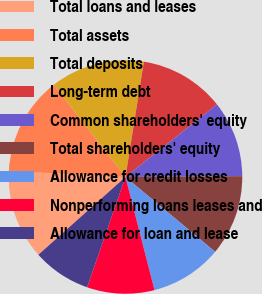Convert chart. <chart><loc_0><loc_0><loc_500><loc_500><pie_chart><fcel>Total loans and leases<fcel>Total assets<fcel>Total deposits<fcel>Long-term debt<fcel>Common shareholders' equity<fcel>Total shareholders' equity<fcel>Allowance for credit losses<fcel>Nonperforming loans leases and<fcel>Allowance for loan and lease<nl><fcel>12.42%<fcel>13.66%<fcel>13.04%<fcel>11.8%<fcel>10.56%<fcel>11.18%<fcel>9.94%<fcel>9.32%<fcel>8.07%<nl></chart> 